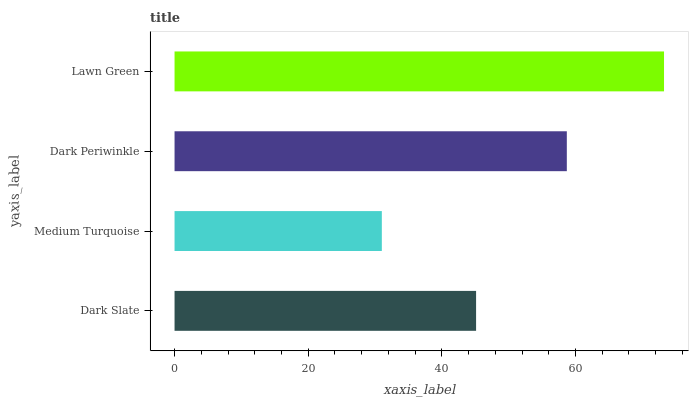Is Medium Turquoise the minimum?
Answer yes or no. Yes. Is Lawn Green the maximum?
Answer yes or no. Yes. Is Dark Periwinkle the minimum?
Answer yes or no. No. Is Dark Periwinkle the maximum?
Answer yes or no. No. Is Dark Periwinkle greater than Medium Turquoise?
Answer yes or no. Yes. Is Medium Turquoise less than Dark Periwinkle?
Answer yes or no. Yes. Is Medium Turquoise greater than Dark Periwinkle?
Answer yes or no. No. Is Dark Periwinkle less than Medium Turquoise?
Answer yes or no. No. Is Dark Periwinkle the high median?
Answer yes or no. Yes. Is Dark Slate the low median?
Answer yes or no. Yes. Is Medium Turquoise the high median?
Answer yes or no. No. Is Lawn Green the low median?
Answer yes or no. No. 